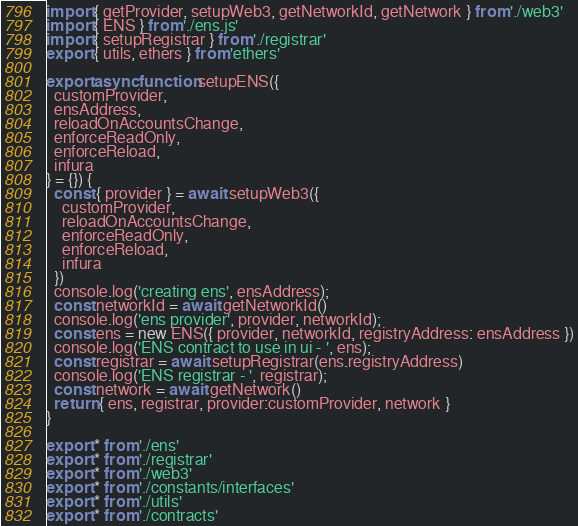Convert code to text. <code><loc_0><loc_0><loc_500><loc_500><_JavaScript_>import { getProvider, setupWeb3, getNetworkId, getNetwork } from './web3'
import { ENS } from './ens.js'
import { setupRegistrar } from './registrar'
export { utils, ethers } from 'ethers'

export async function setupENS({
  customProvider,
  ensAddress,
  reloadOnAccountsChange,
  enforceReadOnly,
  enforceReload,
  infura
} = {}) {
  const { provider } = await setupWeb3({
    customProvider,
    reloadOnAccountsChange,
    enforceReadOnly,
    enforceReload,
    infura
  })
  console.log('creating ens', ensAddress);
  const networkId = await getNetworkId()
  console.log('ens provider', provider, networkId);
  const ens = new ENS({ provider, networkId, registryAddress: ensAddress })
  console.log('ENS contract to use in ui - ', ens);
  const registrar = await setupRegistrar(ens.registryAddress)
  console.log('ENS registrar - ', registrar);
  const network = await getNetwork()
  return { ens, registrar, provider:customProvider, network }
}

export * from './ens'
export * from './registrar'
export * from './web3'
export * from './constants/interfaces'
export * from './utils'
export * from './contracts'
</code> 